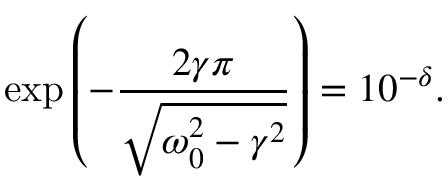Convert formula to latex. <formula><loc_0><loc_0><loc_500><loc_500>\exp \left ( - \frac { 2 \gamma \pi } { \sqrt { \omega _ { 0 } ^ { 2 } - \gamma ^ { 2 } } } \right ) = 1 0 ^ { - \delta } .</formula> 